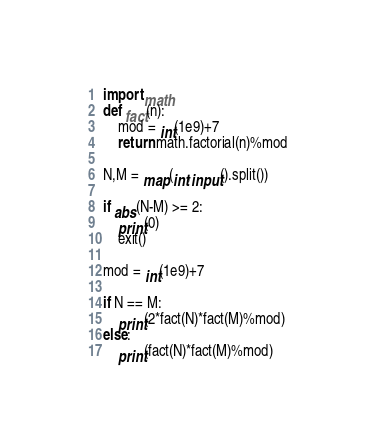<code> <loc_0><loc_0><loc_500><loc_500><_Python_>import math
def fact(n):
    mod = int(1e9)+7
    return math.factorial(n)%mod

N,M = map(int,input().split())

if abs(N-M) >= 2:
    print(0)
    exit()

mod = int(1e9)+7

if N == M:
    print(2*fact(N)*fact(M)%mod)
else:
    print(fact(N)*fact(M)%mod)</code> 